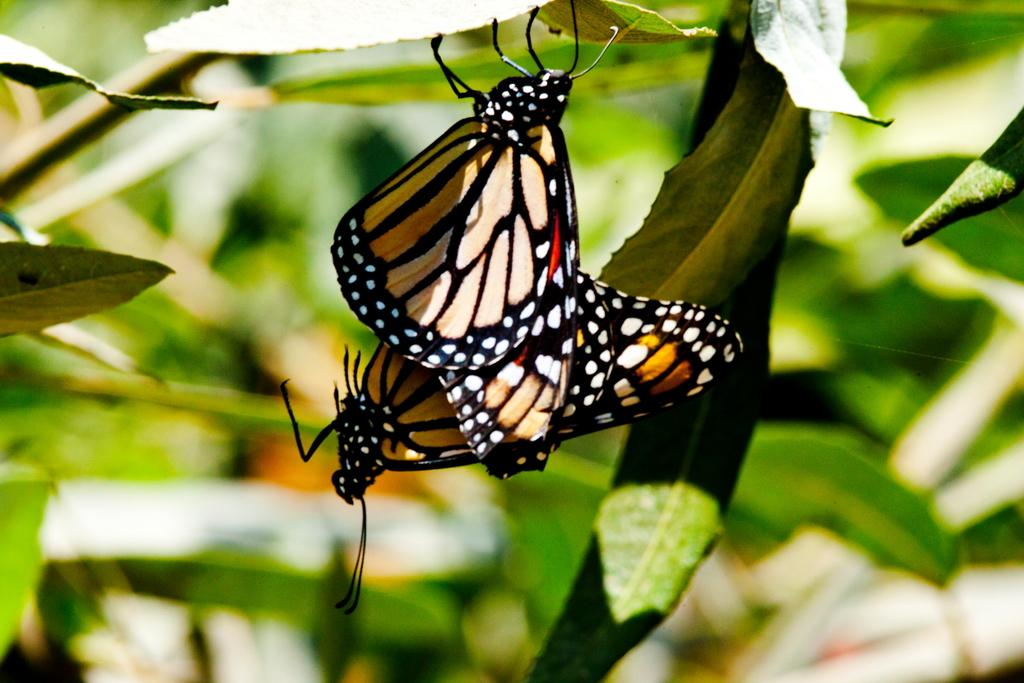How many butterflies are in the image? There are two butterflies in the image. Where are the butterflies located? The butterflies are on a leaf. Can you describe the background of the image? The background of the image is blurred. What is the tendency of the queen in the image? There is no queen present in the image, as it features two butterflies on a leaf with a blurred background. 